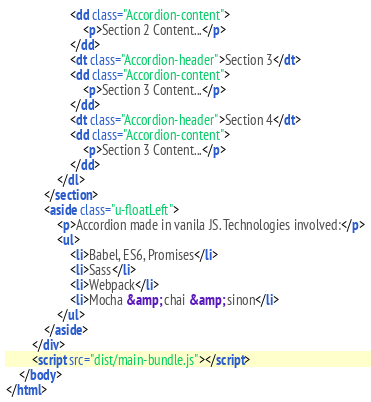<code> <loc_0><loc_0><loc_500><loc_500><_HTML_>                    <dd class="Accordion-content">
                        <p>Section 2 Content...</p>
                    </dd>
                    <dt class="Accordion-header">Section 3</dt>
                    <dd class="Accordion-content">
                        <p>Section 3 Content...</p>
                    </dd>
                    <dt class="Accordion-header">Section 4</dt>
                    <dd class="Accordion-content">
                        <p>Section 3 Content...</p>
                    </dd>
                </dl>
            </section>
            <aside class="u-floatLeft">
                <p>Accordion made in vanila JS. Technologies involved:</p>
                <ul>
                    <li>Babel, ES6, Promises</li>
                    <li>Sass</li>
                    <li>Webpack</li>
                    <li>Mocha &amp; chai &amp; sinon</li>
                </ul>
            </aside>
        </div>
        <script src="dist/main-bundle.js"></script>
    </body>
</html>
</code> 